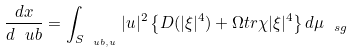<formula> <loc_0><loc_0><loc_500><loc_500>\frac { d x } { d \ u b } = \int _ { S _ { \ u b , u } } | u | ^ { 2 } \left \{ D ( | \xi | ^ { 4 } ) + \Omega t r \chi | \xi | ^ { 4 } \right \} d \mu _ { \ s g }</formula> 